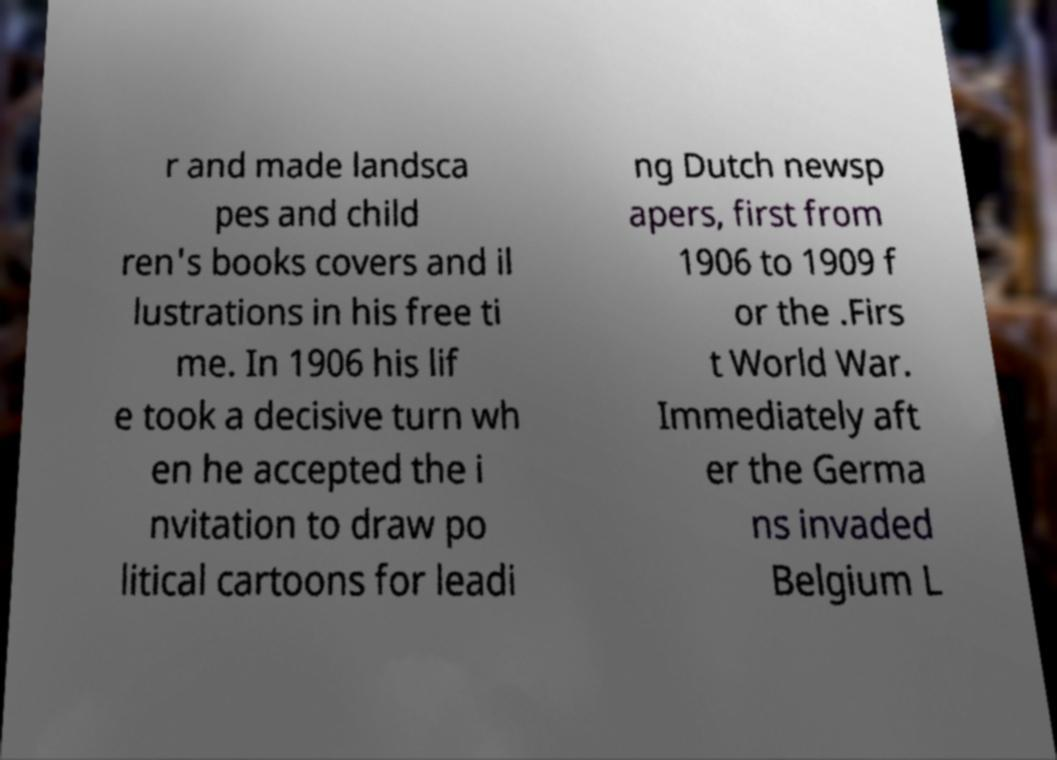Could you extract and type out the text from this image? r and made landsca pes and child ren's books covers and il lustrations in his free ti me. In 1906 his lif e took a decisive turn wh en he accepted the i nvitation to draw po litical cartoons for leadi ng Dutch newsp apers, first from 1906 to 1909 f or the .Firs t World War. Immediately aft er the Germa ns invaded Belgium L 